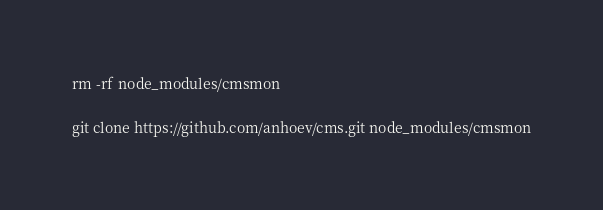<code> <loc_0><loc_0><loc_500><loc_500><_Bash_>rm -rf node_modules/cmsmon

git clone https://github.com/anhoev/cms.git node_modules/cmsmon
</code> 